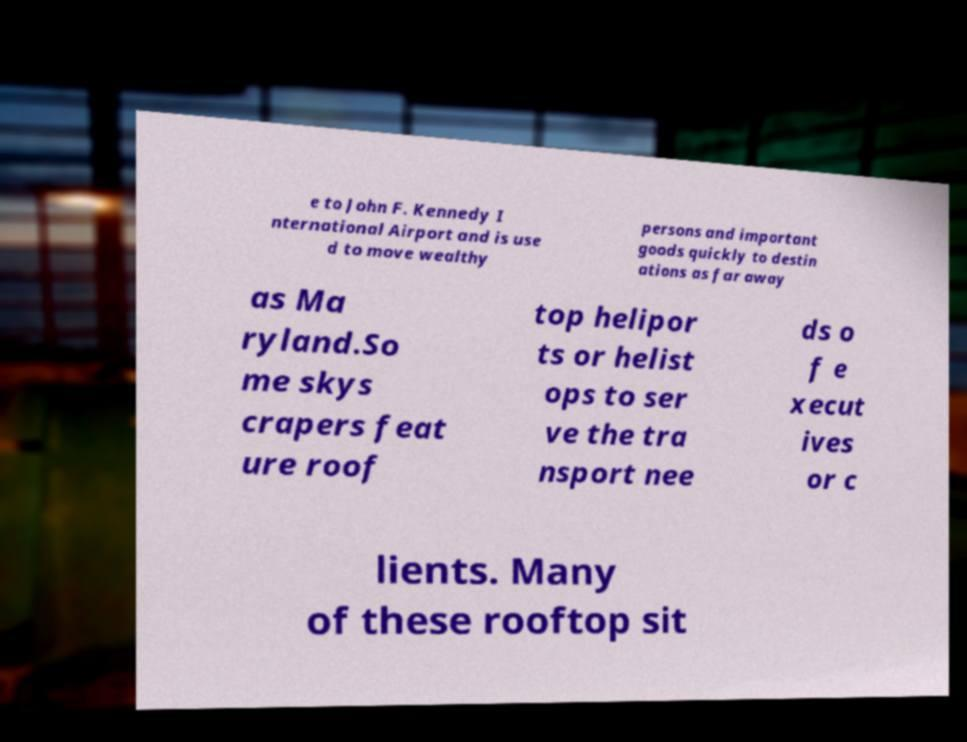Could you extract and type out the text from this image? e to John F. Kennedy I nternational Airport and is use d to move wealthy persons and important goods quickly to destin ations as far away as Ma ryland.So me skys crapers feat ure roof top helipor ts or helist ops to ser ve the tra nsport nee ds o f e xecut ives or c lients. Many of these rooftop sit 